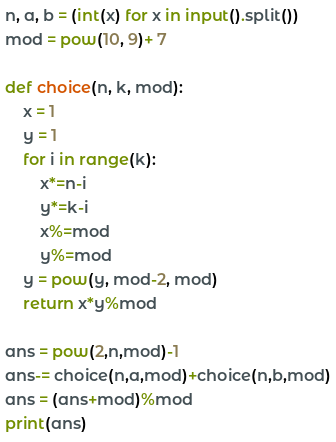<code> <loc_0><loc_0><loc_500><loc_500><_Python_>n, a, b = (int(x) for x in input().split())
mod = pow(10, 9)+ 7

def choice(n, k, mod):
    x = 1
    y = 1
    for i in range(k):
        x*=n-i
        y*=k-i
        x%=mod
        y%=mod
    y = pow(y, mod-2, mod)
    return x*y%mod

ans = pow(2,n,mod)-1
ans-= choice(n,a,mod)+choice(n,b,mod)
ans = (ans+mod)%mod
print(ans)</code> 